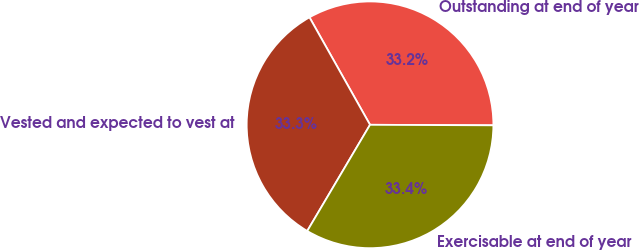<chart> <loc_0><loc_0><loc_500><loc_500><pie_chart><fcel>Outstanding at end of year<fcel>Vested and expected to vest at<fcel>Exercisable at end of year<nl><fcel>33.23%<fcel>33.33%<fcel>33.43%<nl></chart> 